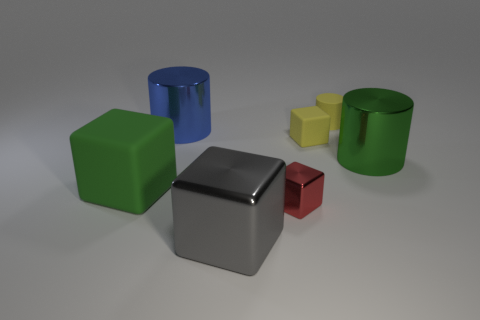Subtract all yellow blocks. How many blocks are left? 3 Add 2 large brown shiny spheres. How many objects exist? 9 Subtract all blue cylinders. How many cylinders are left? 2 Subtract all blocks. How many objects are left? 3 Subtract 2 cubes. How many cubes are left? 2 Subtract all green cylinders. Subtract all purple spheres. How many cylinders are left? 2 Subtract all cyan spheres. How many yellow cylinders are left? 1 Subtract all small red metallic things. Subtract all big green matte cubes. How many objects are left? 5 Add 7 metallic blocks. How many metallic blocks are left? 9 Add 4 big gray metal cubes. How many big gray metal cubes exist? 5 